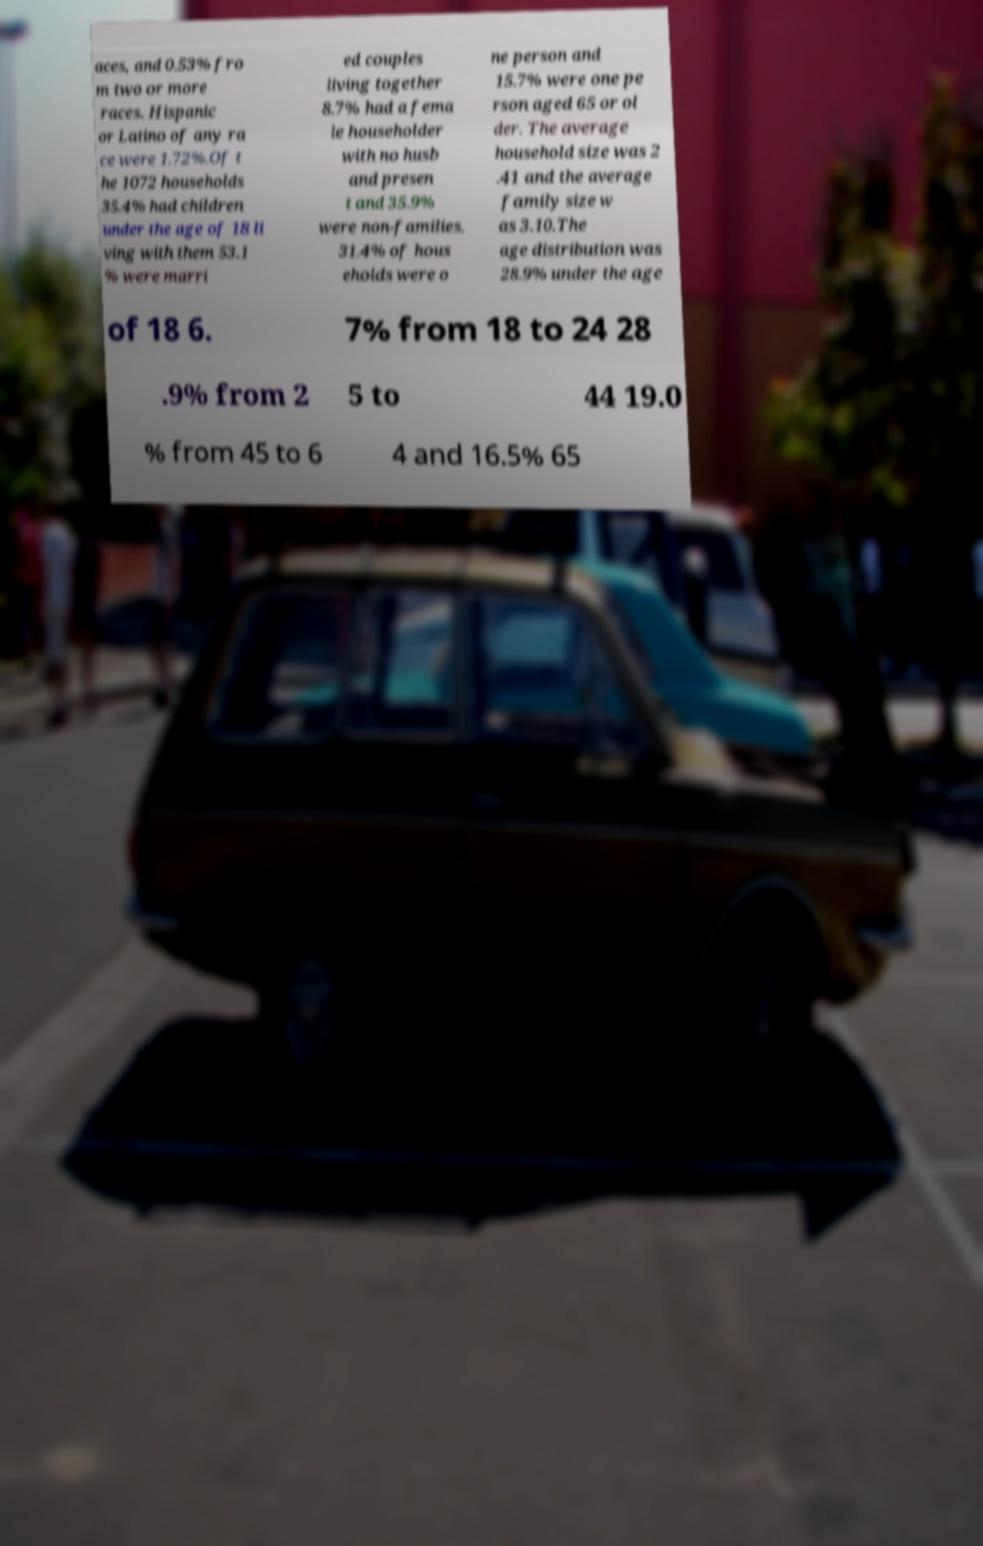Could you assist in decoding the text presented in this image and type it out clearly? aces, and 0.53% fro m two or more races. Hispanic or Latino of any ra ce were 1.72%.Of t he 1072 households 35.4% had children under the age of 18 li ving with them 53.1 % were marri ed couples living together 8.7% had a fema le householder with no husb and presen t and 35.9% were non-families. 31.4% of hous eholds were o ne person and 15.7% were one pe rson aged 65 or ol der. The average household size was 2 .41 and the average family size w as 3.10.The age distribution was 28.9% under the age of 18 6. 7% from 18 to 24 28 .9% from 2 5 to 44 19.0 % from 45 to 6 4 and 16.5% 65 